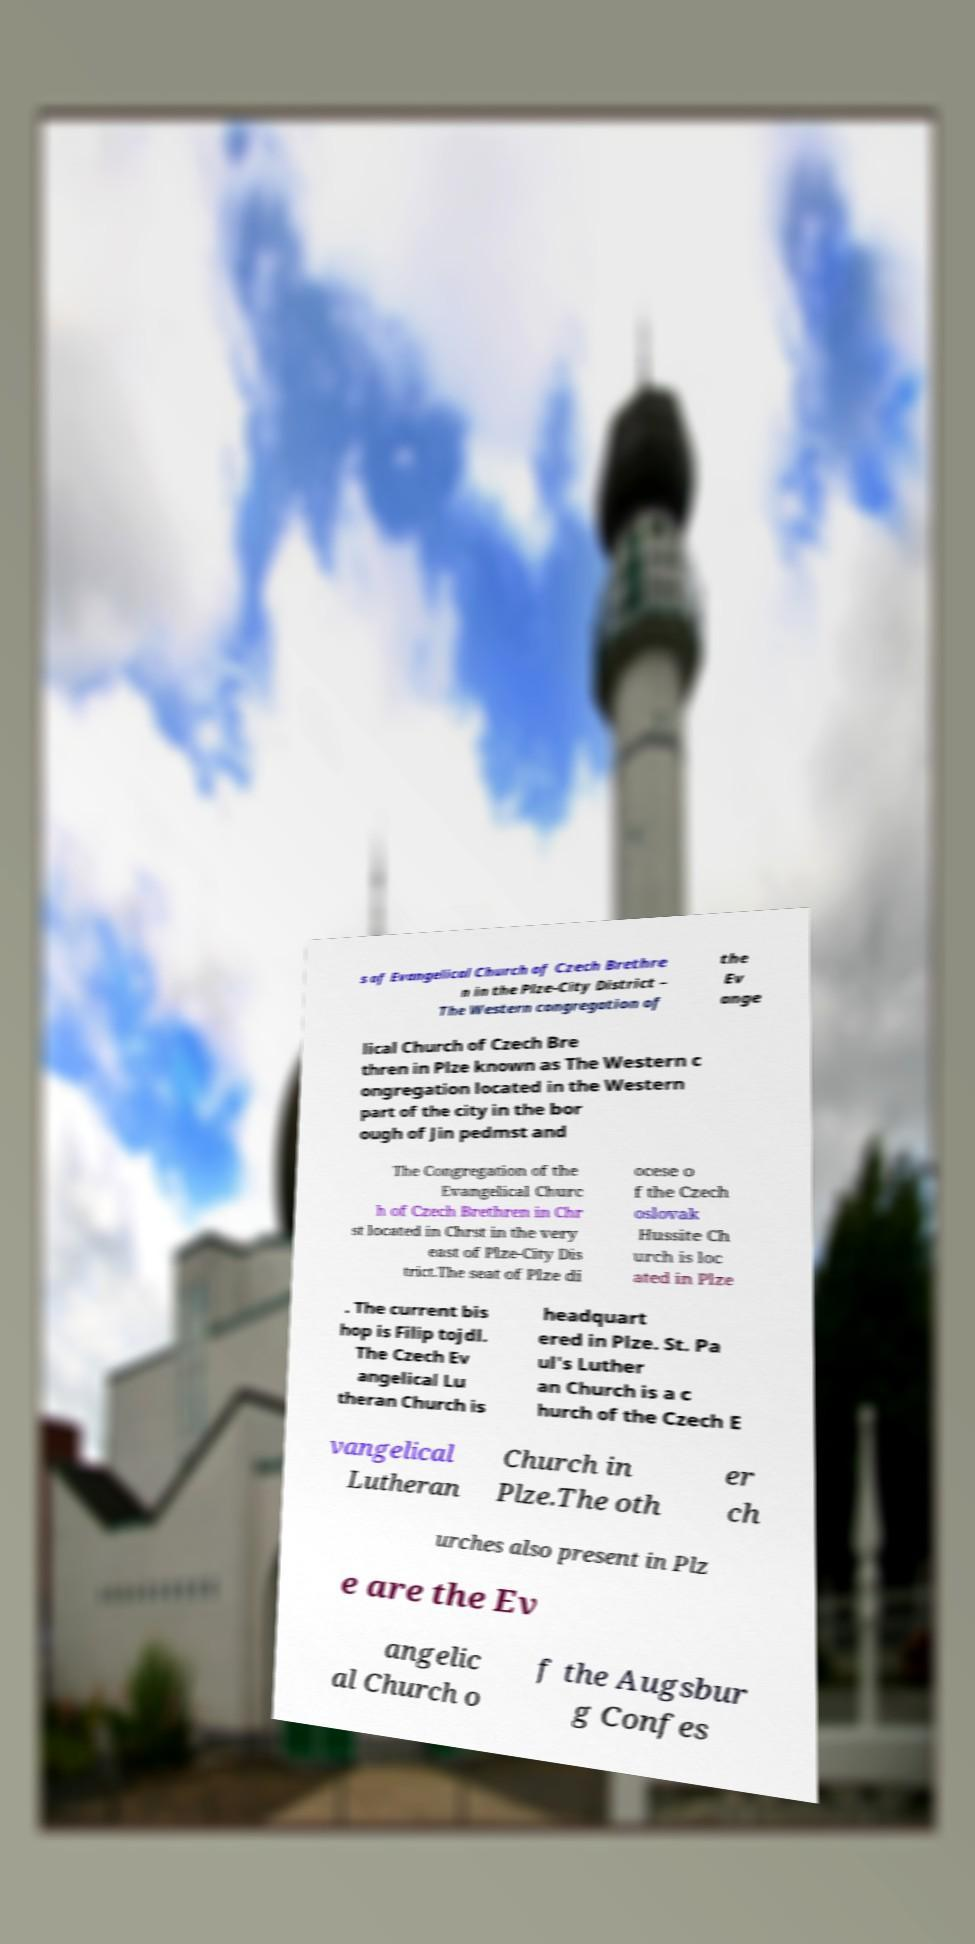Please read and relay the text visible in this image. What does it say? s of Evangelical Church of Czech Brethre n in the Plze-City District – The Western congregation of the Ev ange lical Church of Czech Bre thren in Plze known as The Western c ongregation located in the Western part of the city in the bor ough of Jin pedmst and The Congregation of the Evangelical Churc h of Czech Brethren in Chr st located in Chrst in the very east of Plze-City Dis trict.The seat of Plze di ocese o f the Czech oslovak Hussite Ch urch is loc ated in Plze . The current bis hop is Filip tojdl. The Czech Ev angelical Lu theran Church is headquart ered in Plze. St. Pa ul's Luther an Church is a c hurch of the Czech E vangelical Lutheran Church in Plze.The oth er ch urches also present in Plz e are the Ev angelic al Church o f the Augsbur g Confes 